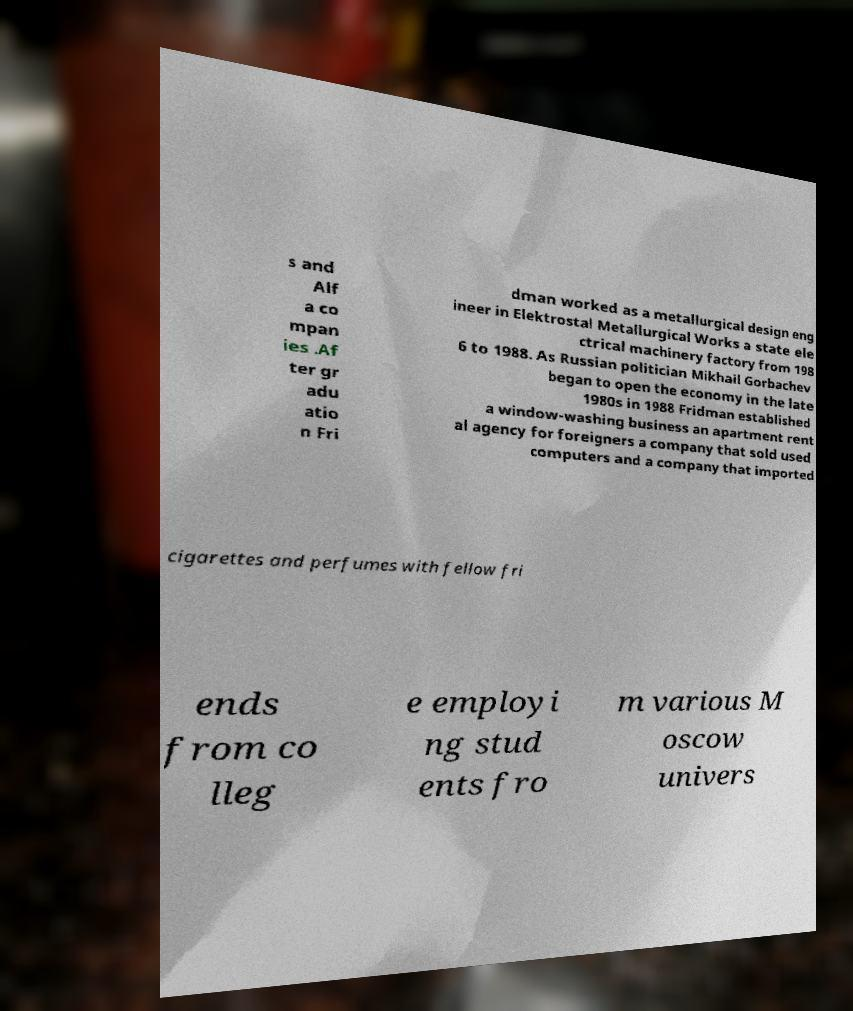For documentation purposes, I need the text within this image transcribed. Could you provide that? s and Alf a co mpan ies .Af ter gr adu atio n Fri dman worked as a metallurgical design eng ineer in Elektrostal Metallurgical Works a state ele ctrical machinery factory from 198 6 to 1988. As Russian politician Mikhail Gorbachev began to open the economy in the late 1980s in 1988 Fridman established a window-washing business an apartment rent al agency for foreigners a company that sold used computers and a company that imported cigarettes and perfumes with fellow fri ends from co lleg e employi ng stud ents fro m various M oscow univers 